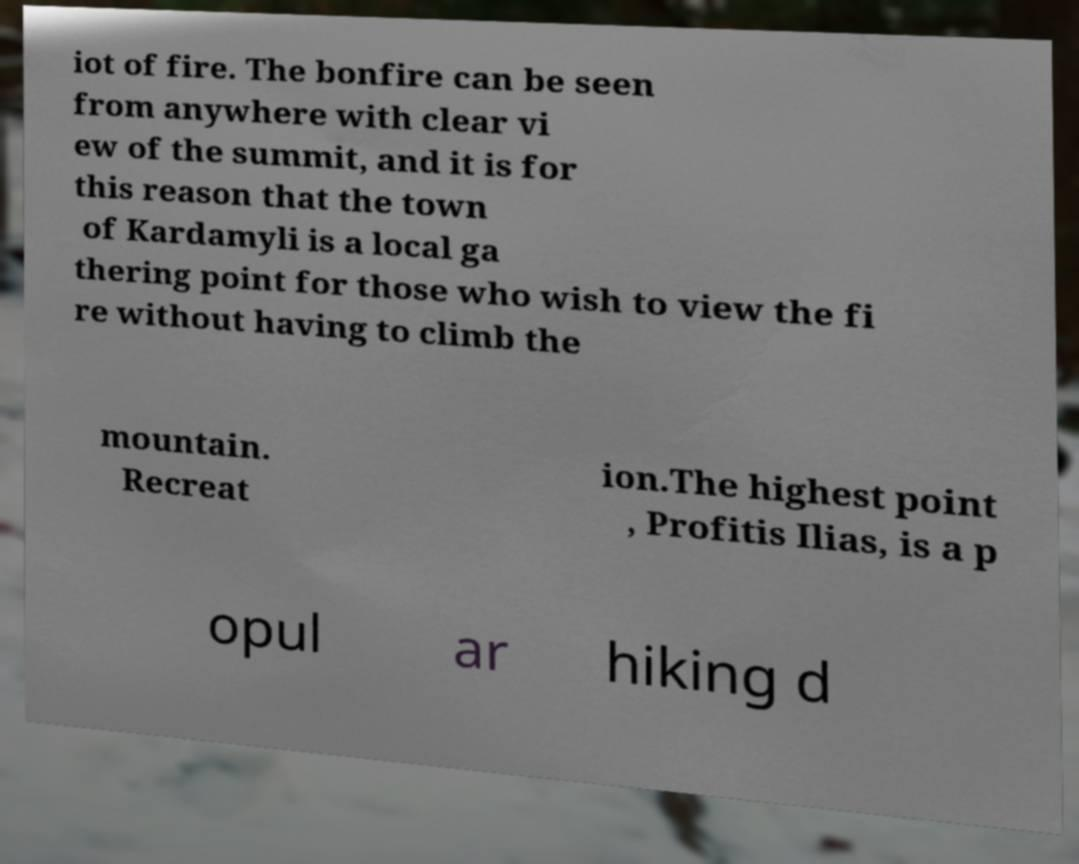Can you accurately transcribe the text from the provided image for me? iot of fire. The bonfire can be seen from anywhere with clear vi ew of the summit, and it is for this reason that the town of Kardamyli is a local ga thering point for those who wish to view the fi re without having to climb the mountain. Recreat ion.The highest point , Profitis Ilias, is a p opul ar hiking d 